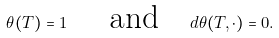<formula> <loc_0><loc_0><loc_500><loc_500>\theta ( T ) = 1 \text { \quad  and\quad  } d \theta ( T , \cdot ) = 0 .</formula> 